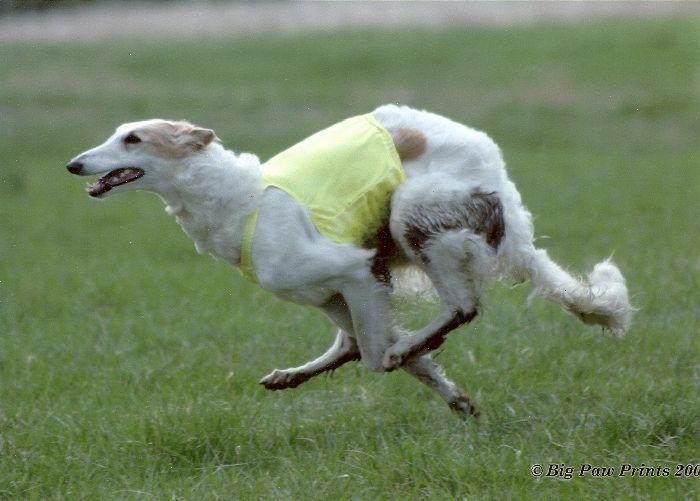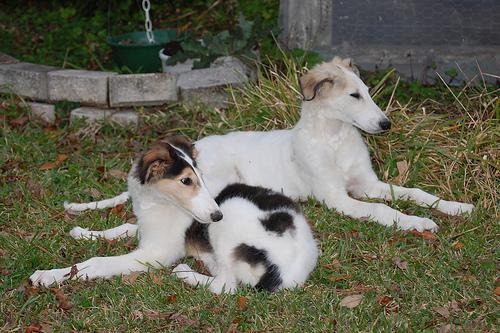The first image is the image on the left, the second image is the image on the right. For the images displayed, is the sentence "One dog is sitting on its bottom." factually correct? Answer yes or no. No. The first image is the image on the left, the second image is the image on the right. Considering the images on both sides, is "One of the dogs is sitting on its haunches." valid? Answer yes or no. No. 